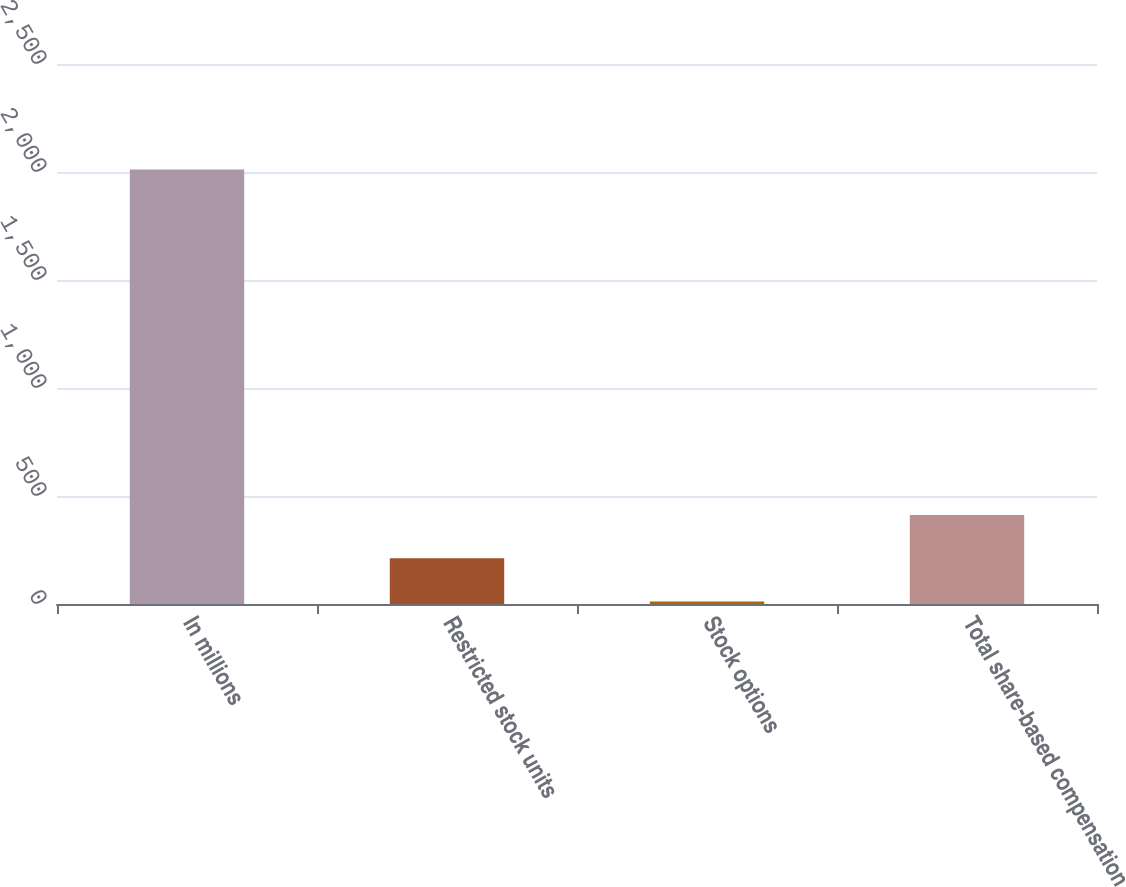Convert chart. <chart><loc_0><loc_0><loc_500><loc_500><bar_chart><fcel>In millions<fcel>Restricted stock units<fcel>Stock options<fcel>Total share-based compensation<nl><fcel>2012<fcel>211.64<fcel>11.6<fcel>411.68<nl></chart> 